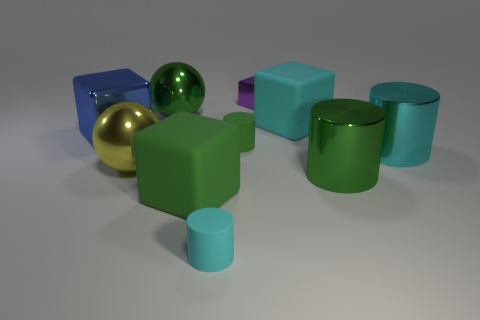Subtract all yellow cubes. How many cyan cylinders are left? 2 Subtract all small cubes. How many cubes are left? 3 Subtract all purple cubes. How many cubes are left? 3 Subtract 2 blocks. How many blocks are left? 2 Subtract all balls. How many objects are left? 8 Subtract all yellow cylinders. Subtract all yellow cubes. How many cylinders are left? 4 Subtract all small matte cylinders. Subtract all yellow objects. How many objects are left? 7 Add 1 big blue objects. How many big blue objects are left? 2 Add 3 green matte cylinders. How many green matte cylinders exist? 4 Subtract 0 purple cylinders. How many objects are left? 10 